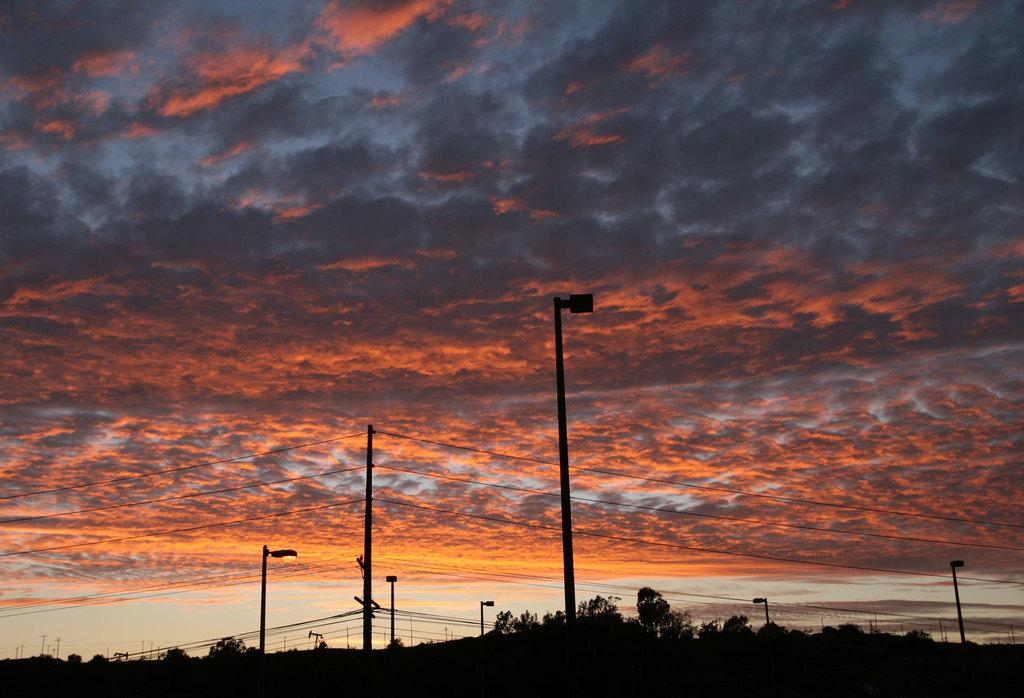What type of natural elements can be seen in the image? There are trees in the image. What type of man-made elements can be seen in the image? There are street lights and poles connected with wires in the image. Where are these elements located in the image? The bottom of the image contains these elements. What is visible at the top of the image? The top of the image has sky with clouds. How does the crow interact with the trees in the image? There is no crow present in the image; it only features trees, street lights, poles connected with wires, and a sky with clouds. What type of vehicle is driving on the street in the image? There is no street or vehicle present in the image; it only shows elements at the bottom and sky with clouds at the top. 